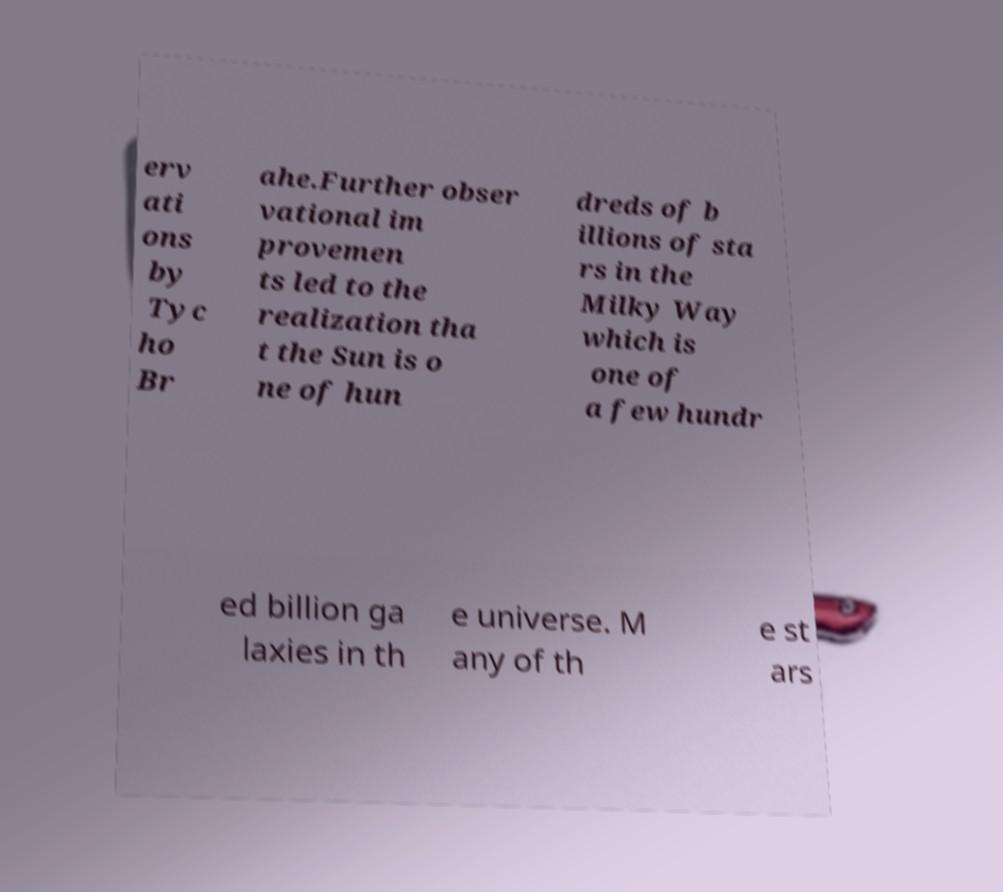There's text embedded in this image that I need extracted. Can you transcribe it verbatim? erv ati ons by Tyc ho Br ahe.Further obser vational im provemen ts led to the realization tha t the Sun is o ne of hun dreds of b illions of sta rs in the Milky Way which is one of a few hundr ed billion ga laxies in th e universe. M any of th e st ars 